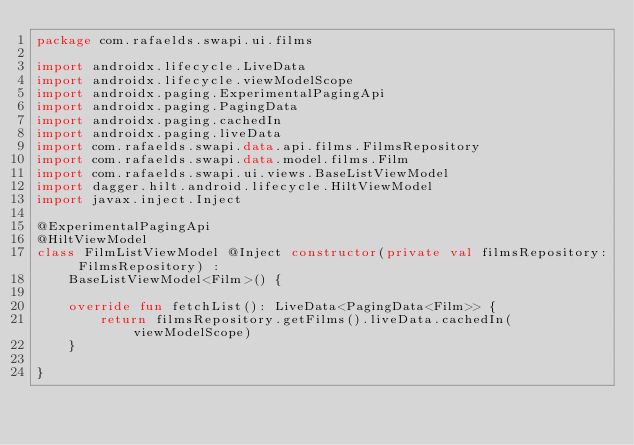<code> <loc_0><loc_0><loc_500><loc_500><_Kotlin_>package com.rafaelds.swapi.ui.films

import androidx.lifecycle.LiveData
import androidx.lifecycle.viewModelScope
import androidx.paging.ExperimentalPagingApi
import androidx.paging.PagingData
import androidx.paging.cachedIn
import androidx.paging.liveData
import com.rafaelds.swapi.data.api.films.FilmsRepository
import com.rafaelds.swapi.data.model.films.Film
import com.rafaelds.swapi.ui.views.BaseListViewModel
import dagger.hilt.android.lifecycle.HiltViewModel
import javax.inject.Inject

@ExperimentalPagingApi
@HiltViewModel
class FilmListViewModel @Inject constructor(private val filmsRepository: FilmsRepository) :
    BaseListViewModel<Film>() {

    override fun fetchList(): LiveData<PagingData<Film>> {
        return filmsRepository.getFilms().liveData.cachedIn(viewModelScope)
    }

}</code> 